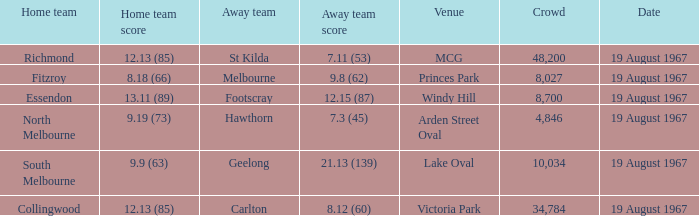When the venue was lake oval what did the home team score? 9.9 (63). 